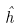<formula> <loc_0><loc_0><loc_500><loc_500>\hat { h }</formula> 